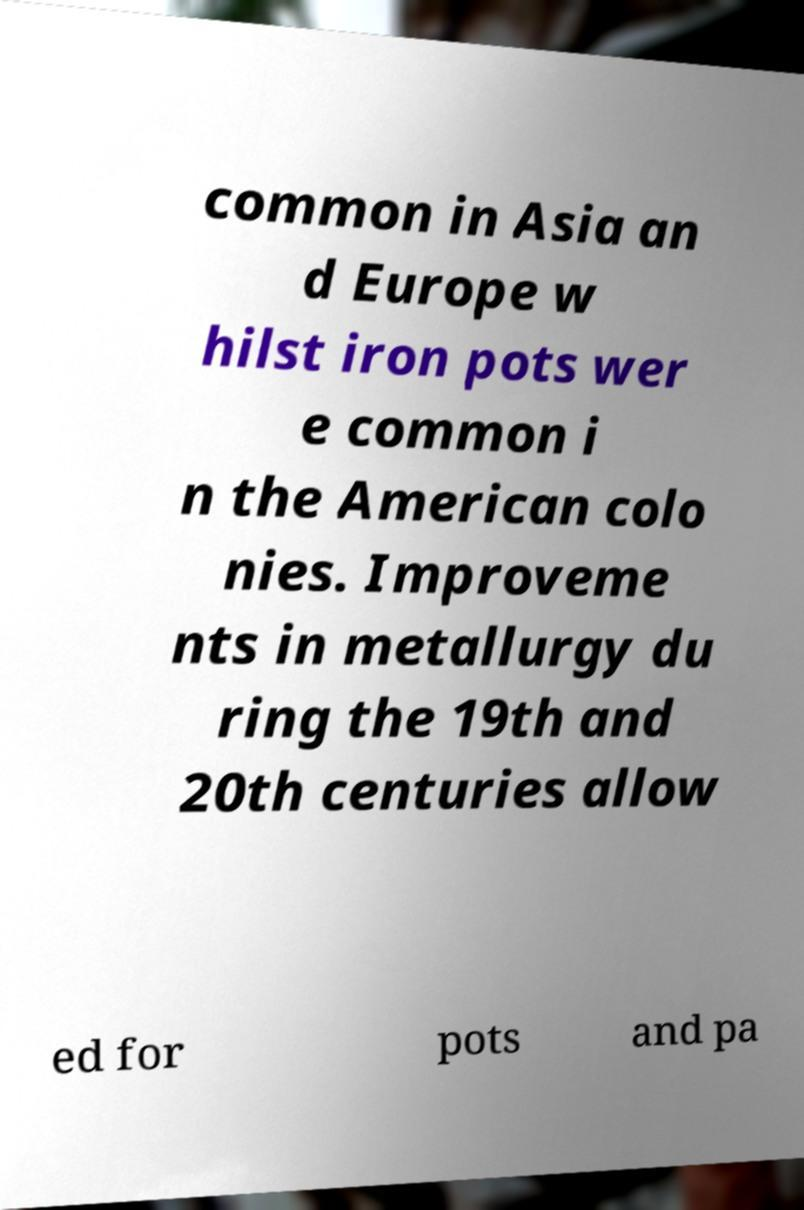I need the written content from this picture converted into text. Can you do that? common in Asia an d Europe w hilst iron pots wer e common i n the American colo nies. Improveme nts in metallurgy du ring the 19th and 20th centuries allow ed for pots and pa 